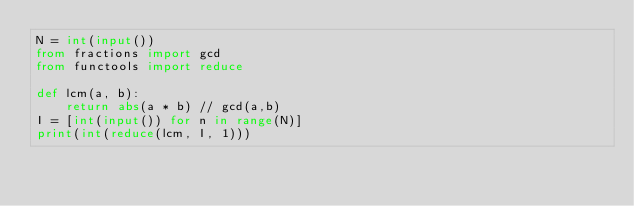<code> <loc_0><loc_0><loc_500><loc_500><_Python_>N = int(input())
from fractions import gcd
from functools import reduce

def lcm(a, b): 
    return abs(a * b) // gcd(a,b)
I = [int(input()) for n in range(N)]
print(int(reduce(lcm, I, 1)))</code> 